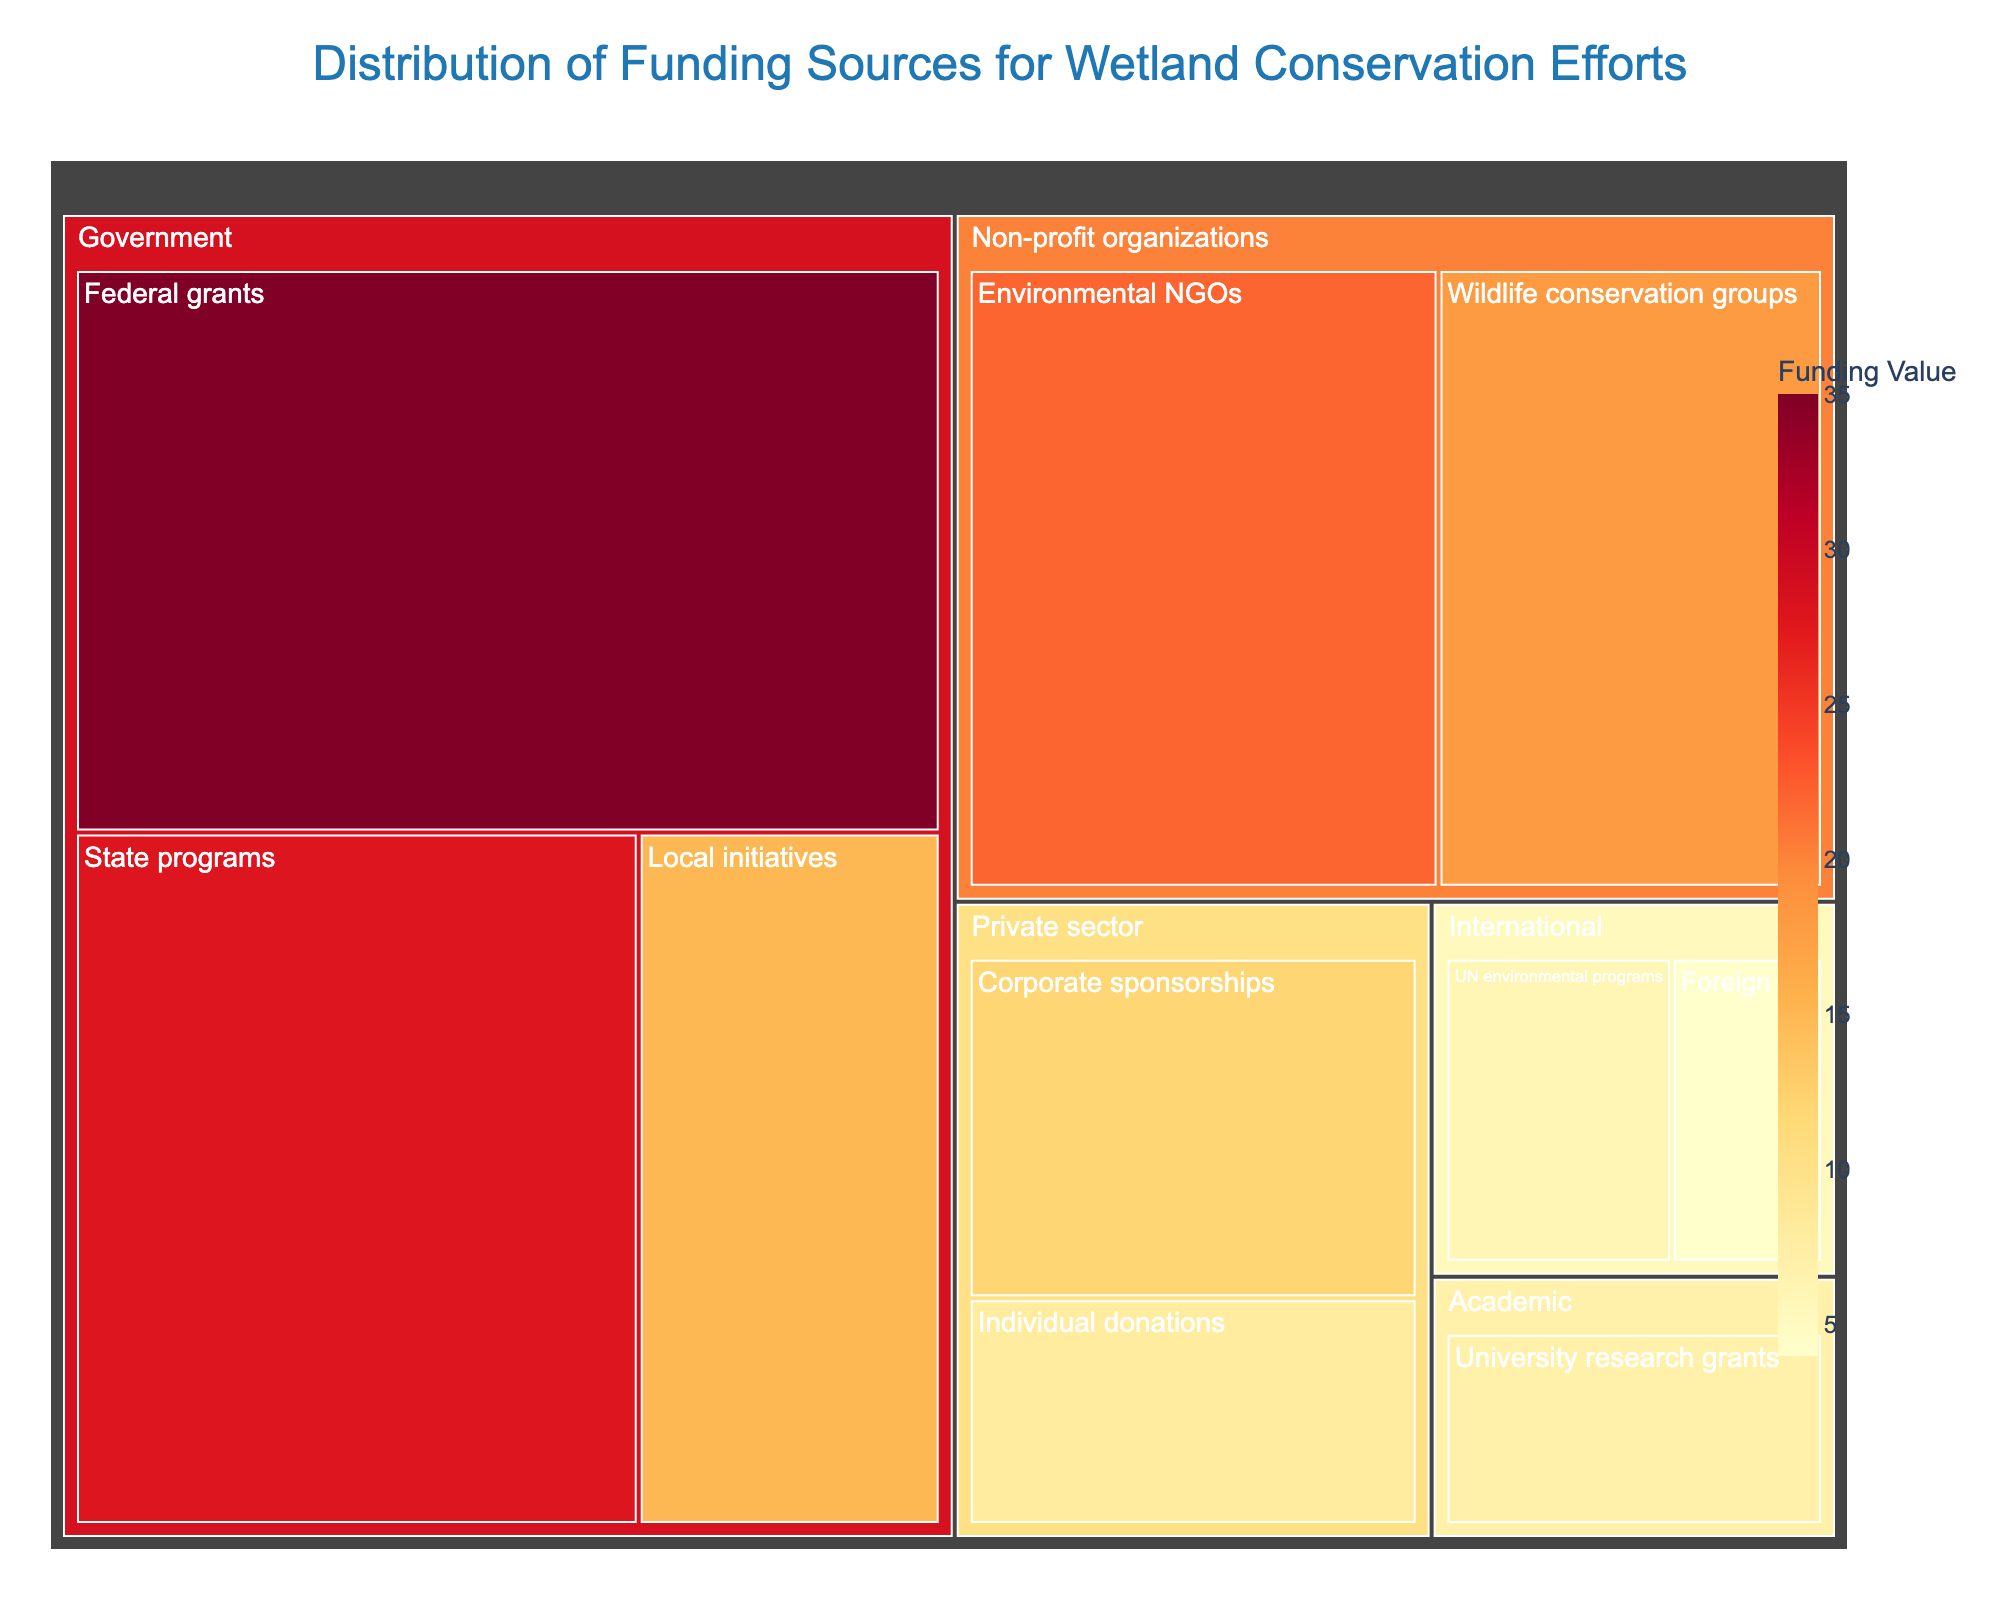What's the title of the figure? The title is displayed at the top center of the figure in a larger font size. It gives a clear description of what the figure is about.
Answer: Distribution of Funding Sources for Wetland Conservation Efforts Which category has the highest overall funding value? To determine this, sum up the values in each category and compare them. Government: 35 + 28 + 15 = 78, Non-profit organizations: 22 + 18 = 40, Private sector: 12 + 8 = 20, International: 6 + 4 = 10, Academic: 7. The Government category has the highest overall funding value.
Answer: Government What is the total funding value from Non-profit organizations? To get the total funding value from Non-profit organizations, sum the values of "Environmental NGOs" and "Wildlife conservation groups". So, 22 + 18 = 40.
Answer: 40 Which subcategory has the lowest funding value, and what is it? Observe the smallest blocks in the figure to identify the subcategory with the lowest value. "Foreign aid" has the smallest block.
Answer: Foreign aid, 4 Compare the funding value of Corporate sponsorships and Individual donations. Which is higher and by how much? Find the values of both subcategories and subtract the smaller from the larger. Corporate sponsorships: 12, Individual donations: 8. Difference: 12 - 8 = 4.
Answer: Corporate sponsorships, by 4 What is the combined funding value of the Private sector? Add the values of Corporate sponsorships and Individual donations. So 12 + 8 = 20.
Answer: 20 Which subcategory within the Government category has the highest funding value? Compare the values of all subcategories within the Government category. Federal grants: 35, State programs: 28, Local initiatives: 15. Federal grants have the highest value.
Answer: Federal grants How much more funding do Environmental NGOs have compared to University research grants? Subtract the value of University research grants from Environmental NGOs. Environmental NGOs: 22, University research grants: 7, therefore 22 - 7 = 15.
Answer: 15 What percentage of the total funding is contributed by State programs? First, find the total funding by summing all values. Total: 35 + 28 + 15 + 22 + 18 + 12 + 8 + 6 + 4 + 7 = 155. Then, calculate the percentage for State programs: (28 / 155) * 100 ≈ 18.06%.
Answer: ≈ 18.06% Which international funding source contributes more, and by how much? Compare the values of "UN environmental programs" and "Foreign aid." UN environmental programs: 6, Foreign aid: 4. The difference is 6 - 4 = 2.
Answer: UN environmental programs, by 2 